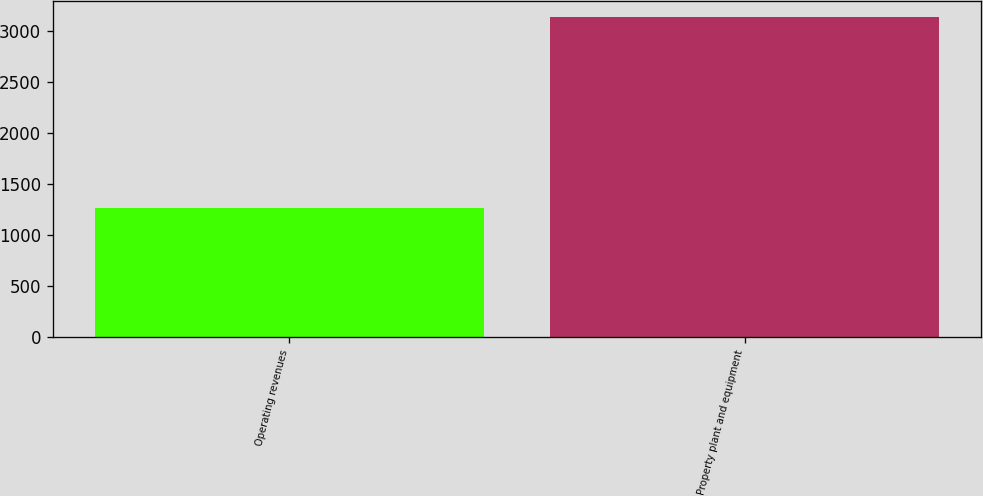<chart> <loc_0><loc_0><loc_500><loc_500><bar_chart><fcel>Operating revenues<fcel>Property plant and equipment<nl><fcel>1271<fcel>3139<nl></chart> 